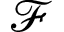Convert formula to latex. <formula><loc_0><loc_0><loc_500><loc_500>\ m a t h s c r { F }</formula> 